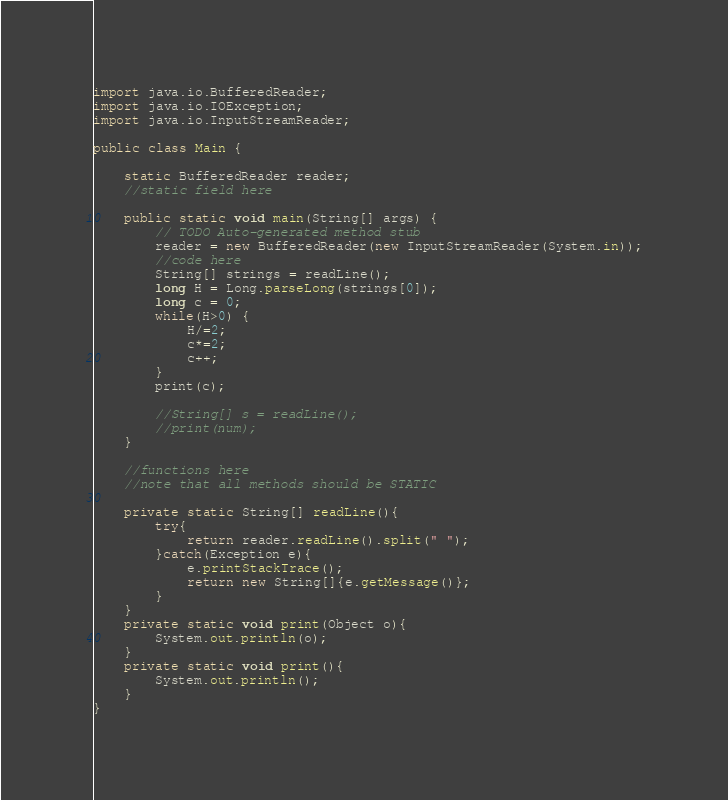Convert code to text. <code><loc_0><loc_0><loc_500><loc_500><_Java_>import java.io.BufferedReader;
import java.io.IOException;
import java.io.InputStreamReader;

public class Main {

	static BufferedReader reader;
	//static field here
	
	public static void main(String[] args) {
		// TODO Auto-generated method stub
		reader = new BufferedReader(new InputStreamReader(System.in));
		//code here
		String[] strings = readLine();
		long H = Long.parseLong(strings[0]);
		long c = 0;
		while(H>0) {
			H/=2;
			c*=2;
			c++;
		}
		print(c);
		
		//String[] s = readLine();
		//print(num);
	}
	
	//functions here
	//note that all methods should be STATIC

	private static String[] readLine(){
		try{
			return reader.readLine().split(" ");
		}catch(Exception e){
			e.printStackTrace();
			return new String[]{e.getMessage()};
		}
	}
	private static void print(Object o){
		System.out.println(o);
	}
	private static void print(){
		System.out.println();
	}
}</code> 